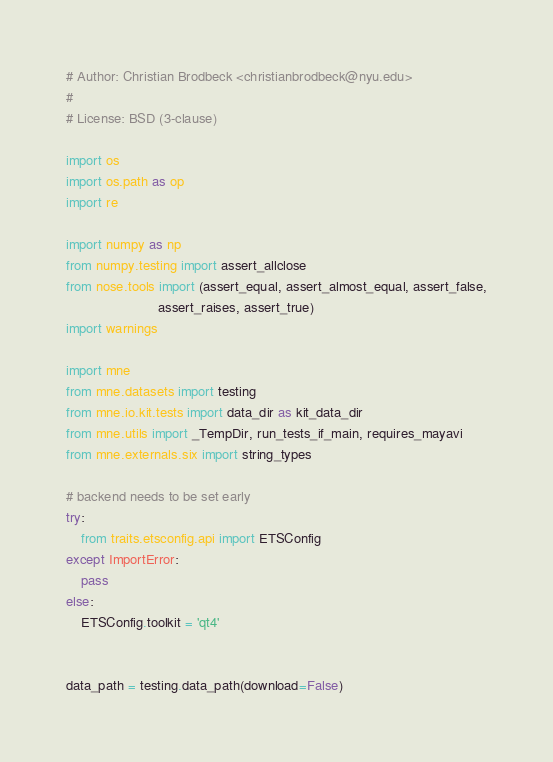Convert code to text. <code><loc_0><loc_0><loc_500><loc_500><_Python_># Author: Christian Brodbeck <christianbrodbeck@nyu.edu>
#
# License: BSD (3-clause)

import os
import os.path as op
import re

import numpy as np
from numpy.testing import assert_allclose
from nose.tools import (assert_equal, assert_almost_equal, assert_false,
                        assert_raises, assert_true)
import warnings

import mne
from mne.datasets import testing
from mne.io.kit.tests import data_dir as kit_data_dir
from mne.utils import _TempDir, run_tests_if_main, requires_mayavi
from mne.externals.six import string_types

# backend needs to be set early
try:
    from traits.etsconfig.api import ETSConfig
except ImportError:
    pass
else:
    ETSConfig.toolkit = 'qt4'


data_path = testing.data_path(download=False)</code> 